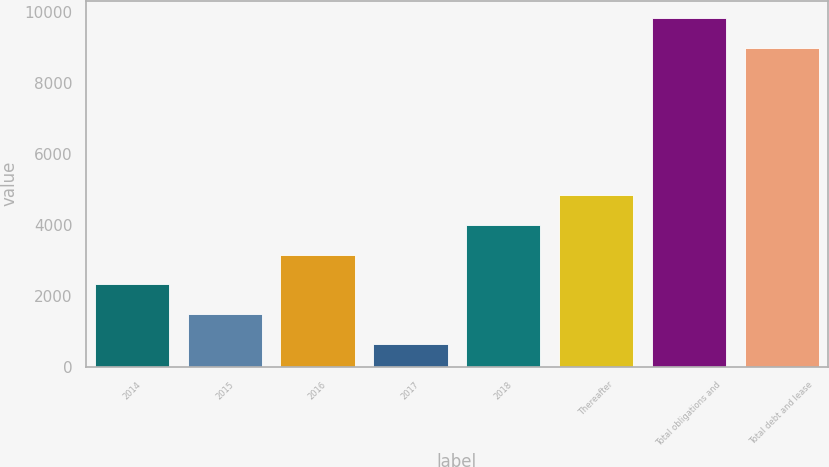Convert chart. <chart><loc_0><loc_0><loc_500><loc_500><bar_chart><fcel>2014<fcel>2015<fcel>2016<fcel>2017<fcel>2018<fcel>Thereafter<fcel>Total obligations and<fcel>Total debt and lease<nl><fcel>2321.6<fcel>1484.3<fcel>3158.9<fcel>647<fcel>3996.2<fcel>4833.5<fcel>9822.3<fcel>8985<nl></chart> 